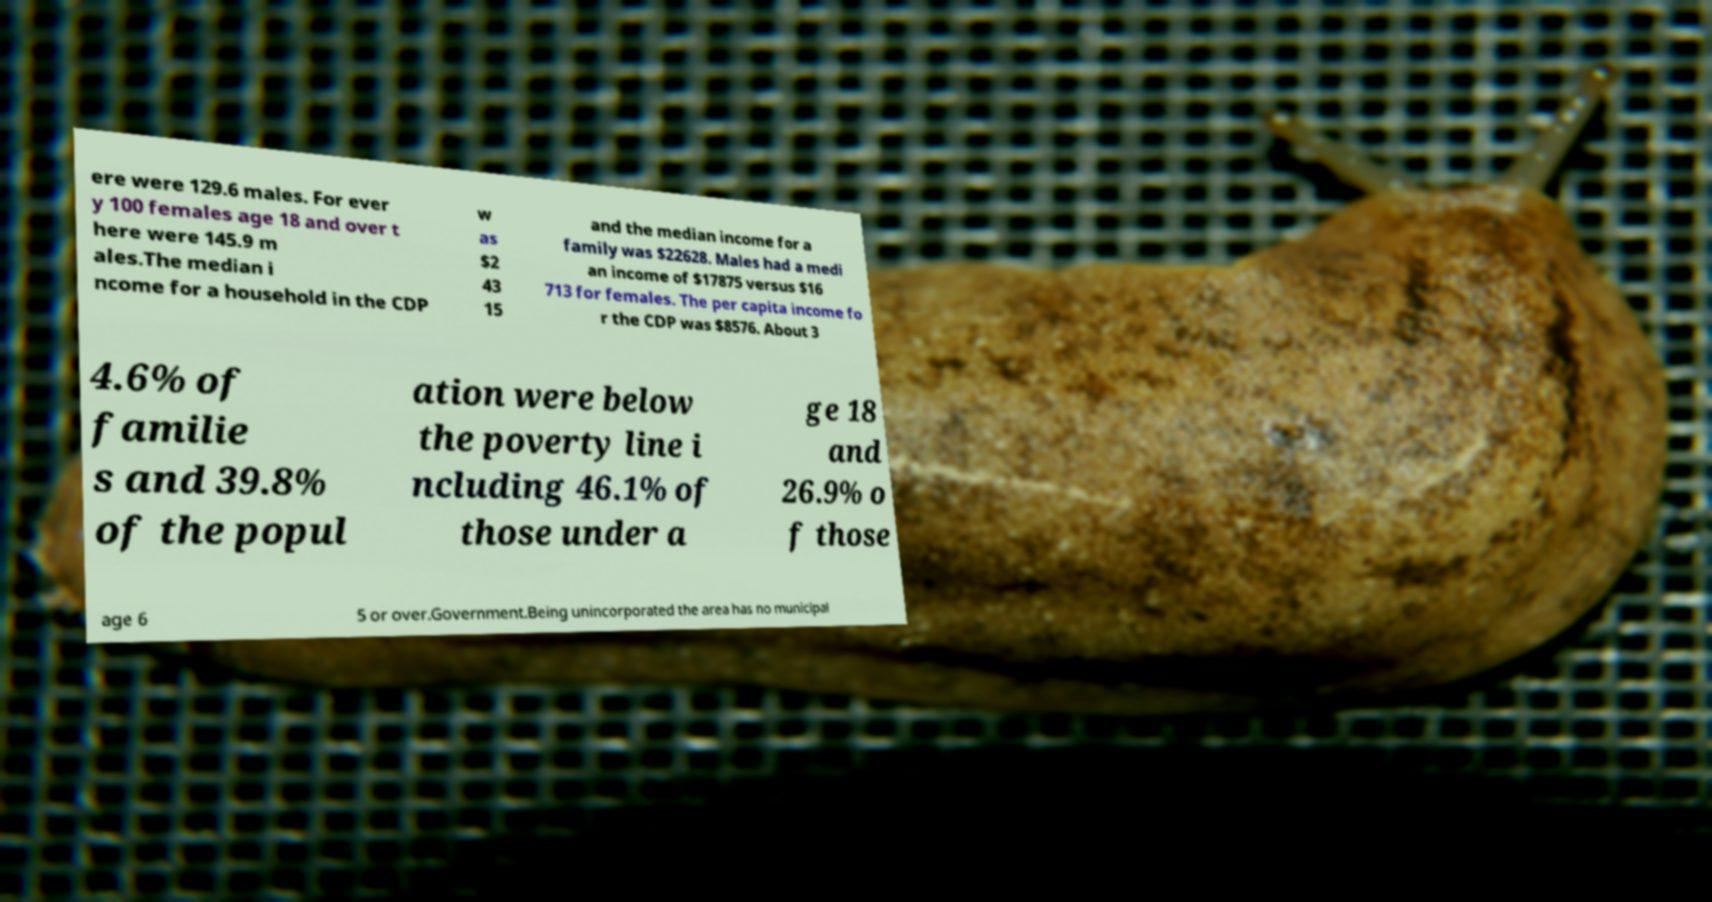Can you accurately transcribe the text from the provided image for me? ere were 129.6 males. For ever y 100 females age 18 and over t here were 145.9 m ales.The median i ncome for a household in the CDP w as $2 43 15 and the median income for a family was $22628. Males had a medi an income of $17875 versus $16 713 for females. The per capita income fo r the CDP was $8576. About 3 4.6% of familie s and 39.8% of the popul ation were below the poverty line i ncluding 46.1% of those under a ge 18 and 26.9% o f those age 6 5 or over.Government.Being unincorporated the area has no municipal 